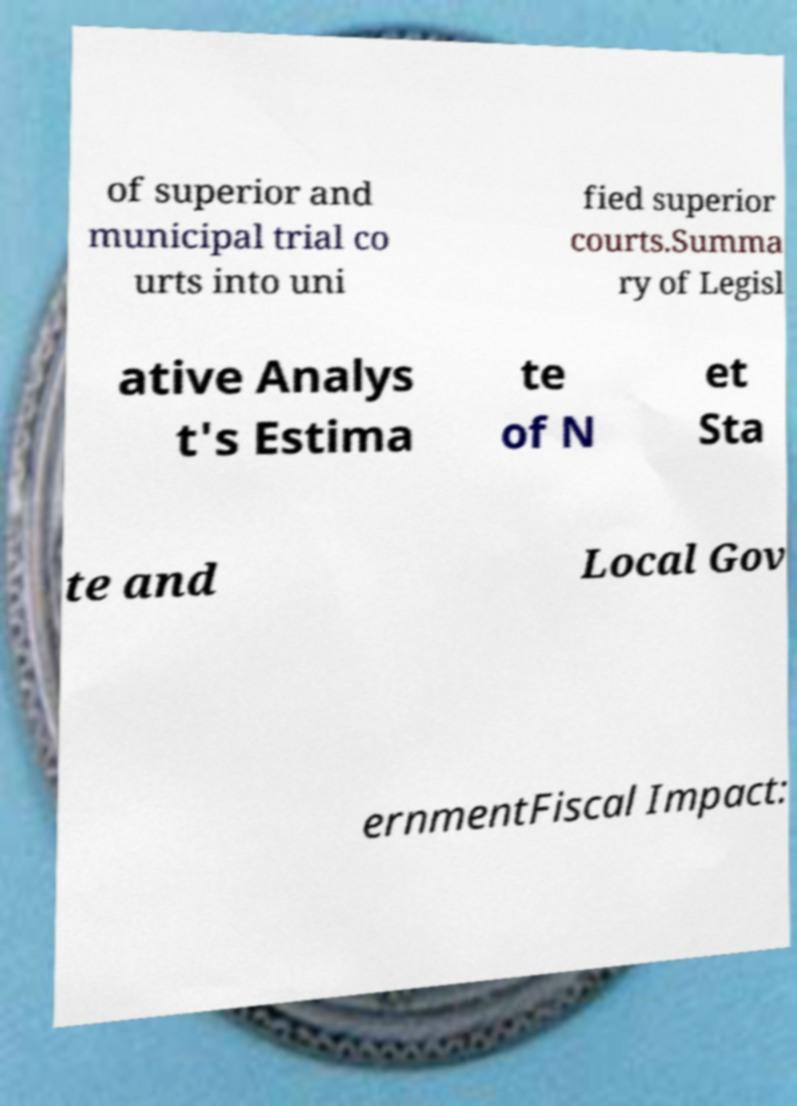Can you accurately transcribe the text from the provided image for me? of superior and municipal trial co urts into uni fied superior courts.Summa ry of Legisl ative Analys t's Estima te of N et Sta te and Local Gov ernmentFiscal Impact: 